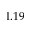<formula> <loc_0><loc_0><loc_500><loc_500>1 . 1 9</formula> 